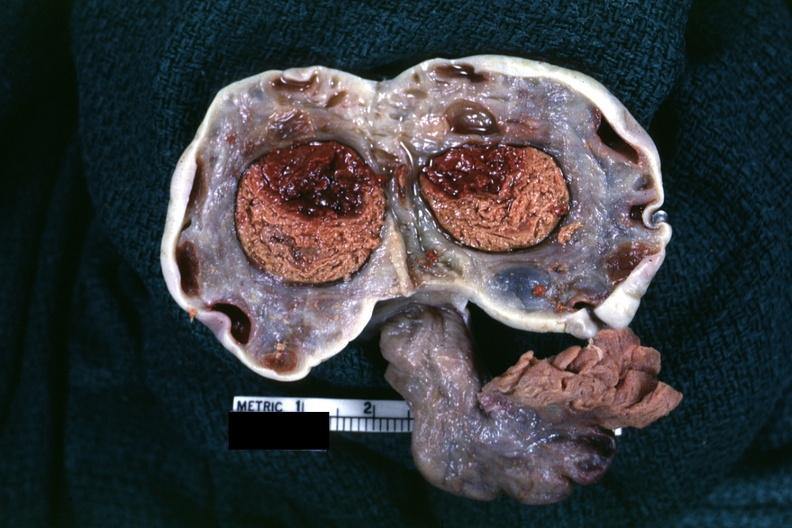what does this image show?
Answer the question using a single word or phrase. Fixed tissue large hemorrhagic cyst in ovary with several corpora lutea for size comparison not sure of diagnosis but sure looks like on autopsy diagnoses did not mention 